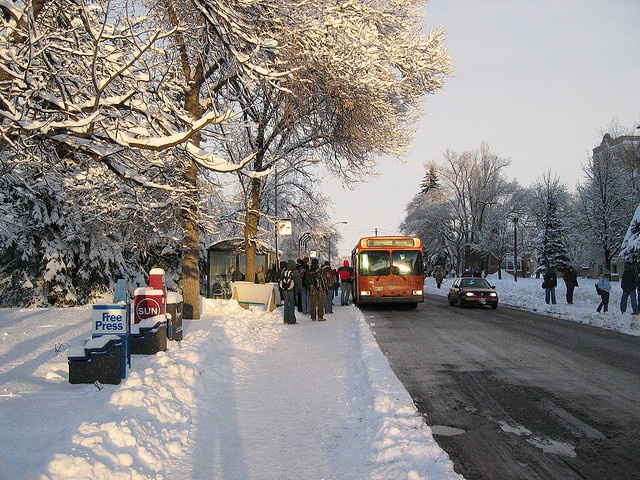Describe the objects in this image and their specific colors. I can see bus in tan, black, brown, maroon, and gray tones, car in tan, black, gray, darkgray, and maroon tones, bench in tan and gray tones, people in tan, black, maroon, gray, and darkgray tones, and people in tan, black, gray, and darkgray tones in this image. 